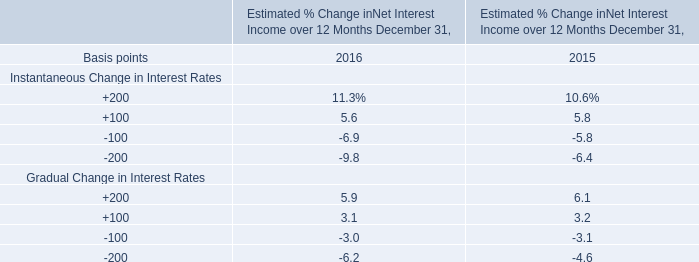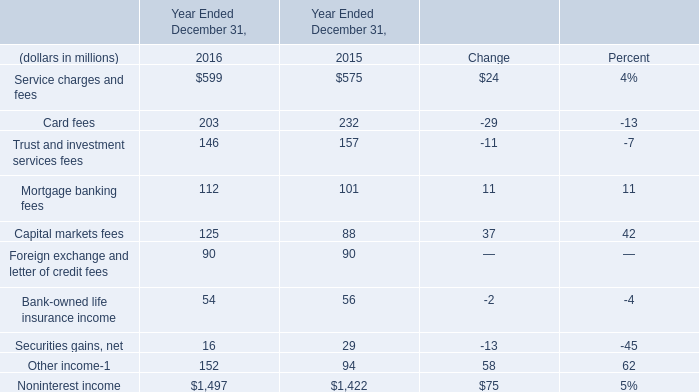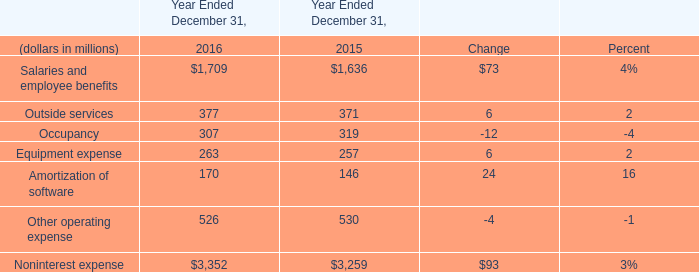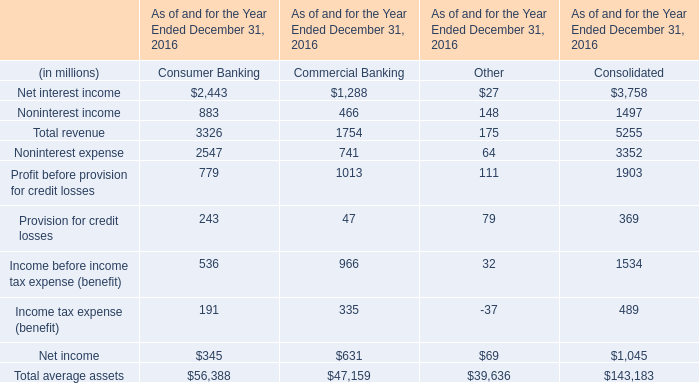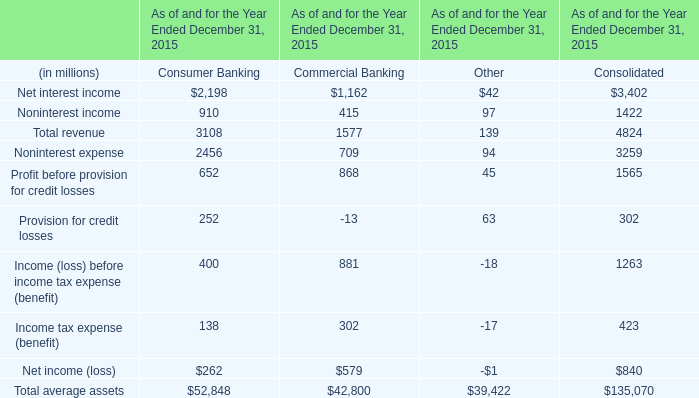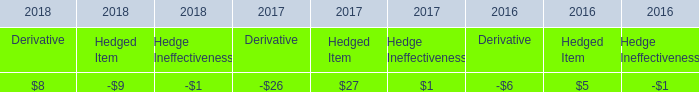Which element makes up more than 10% of the total in 2016? 
Answer: Service charges and fees, Card fees, Other income. 